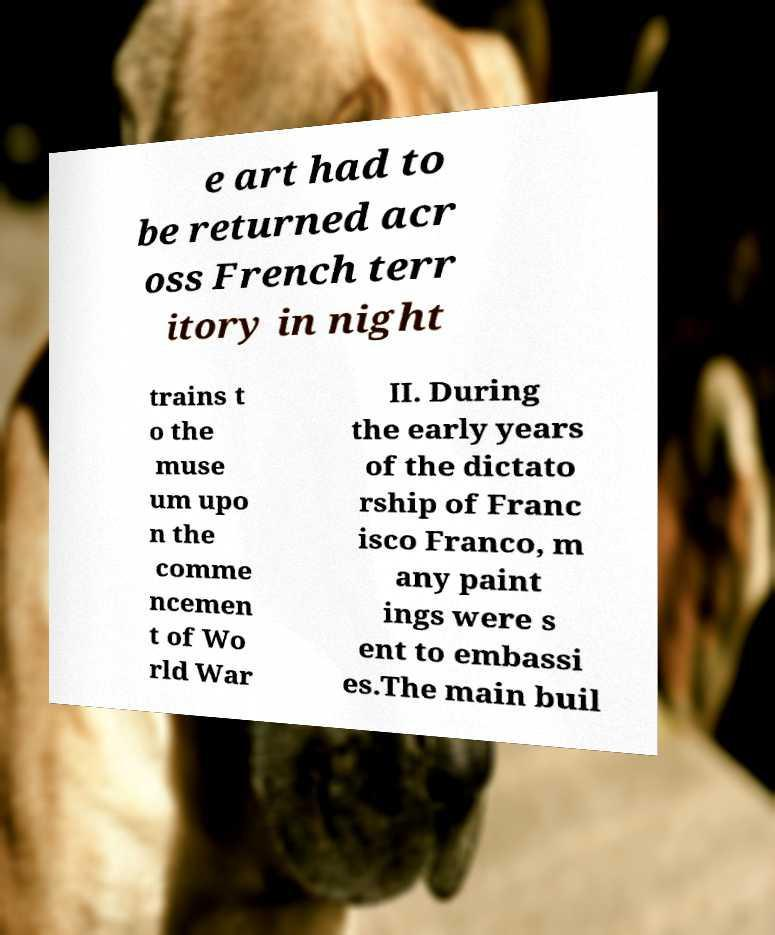Please read and relay the text visible in this image. What does it say? e art had to be returned acr oss French terr itory in night trains t o the muse um upo n the comme ncemen t of Wo rld War II. During the early years of the dictato rship of Franc isco Franco, m any paint ings were s ent to embassi es.The main buil 